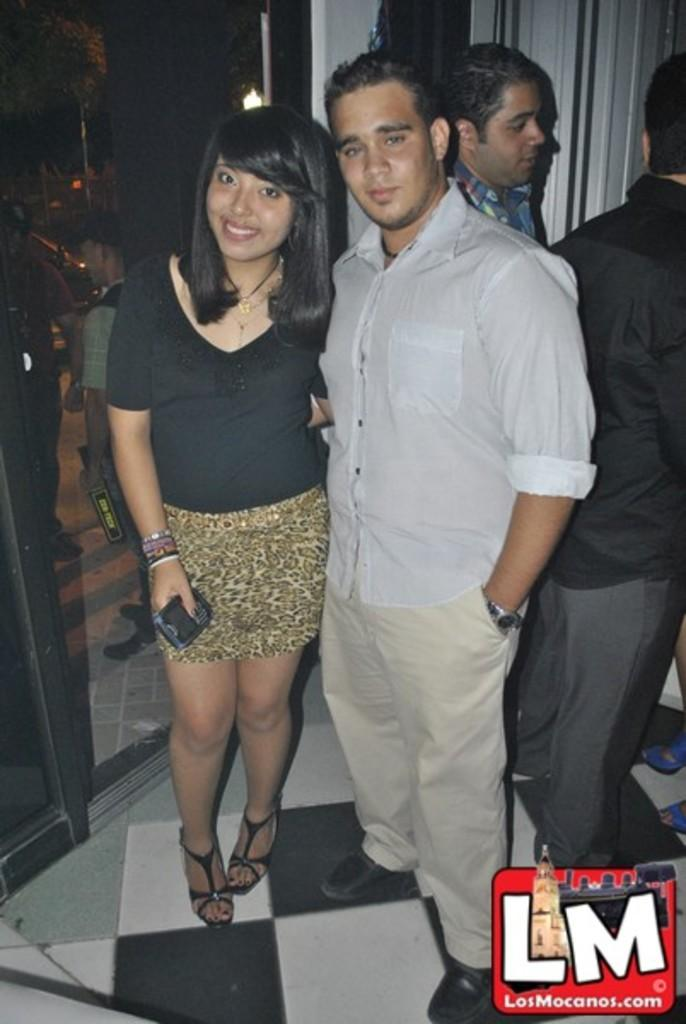How many people are present in the image? There are two people in the image, a woman and a man. What are the positions of the woman and the man in the image? Both the woman and the man are standing on the floor. What is the facial expression of the woman in the image? The woman is smiling. What can be seen in the background of the image? There is glass and light in the background of the image. How many additional people are visible in the background of the image? There are two persons in the background of the image. What type of office furniture can be seen in the image? There is no office furniture present in the image. Can you describe the coach that the woman and man are sitting on in the image? There is no coach present in the image; both the woman and the man are standing on the floor. 